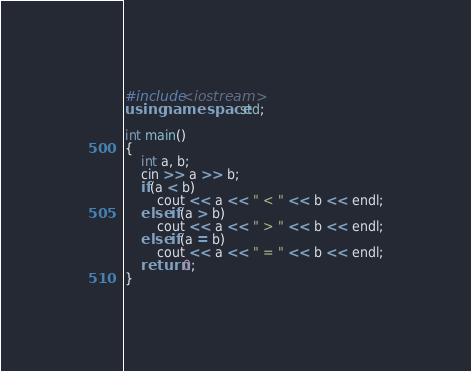<code> <loc_0><loc_0><loc_500><loc_500><_C++_>#include<iostream>
using namespace std;

int main()
{
	int a, b;
	cin >> a >> b;
	if(a < b)
		cout << a << " < " << b << endl;
	else if(a > b)
		cout << a << " > " << b << endl;
	else if(a = b)
		cout << a << " = " << b << endl;
	return 0;
}</code> 